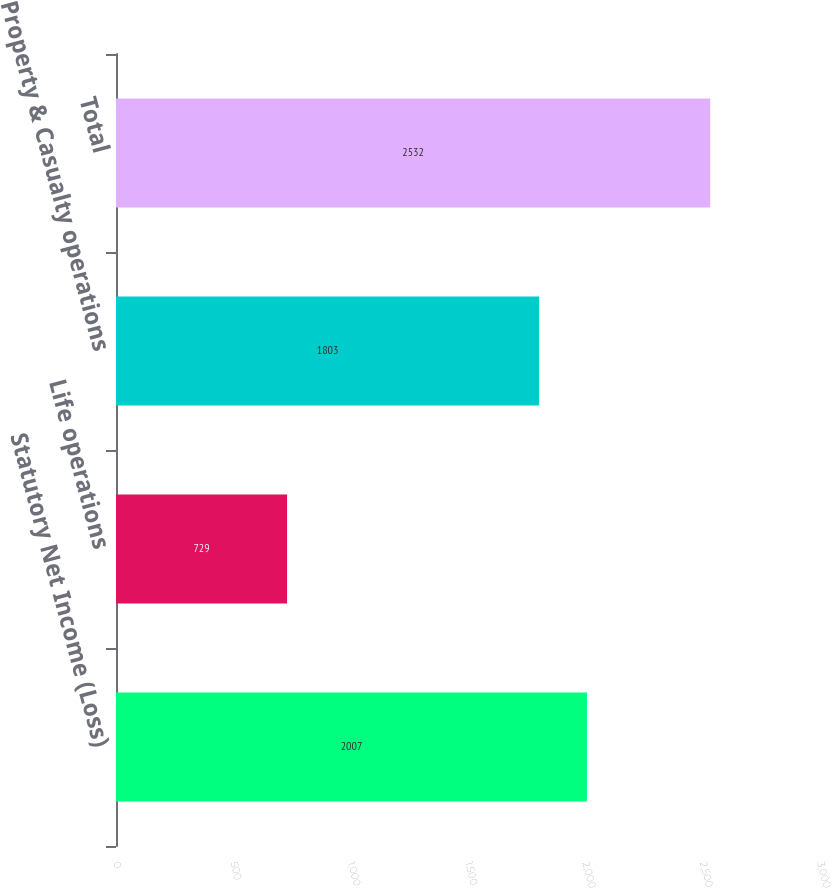Convert chart. <chart><loc_0><loc_0><loc_500><loc_500><bar_chart><fcel>Statutory Net Income (Loss)<fcel>Life operations<fcel>Property & Casualty operations<fcel>Total<nl><fcel>2007<fcel>729<fcel>1803<fcel>2532<nl></chart> 